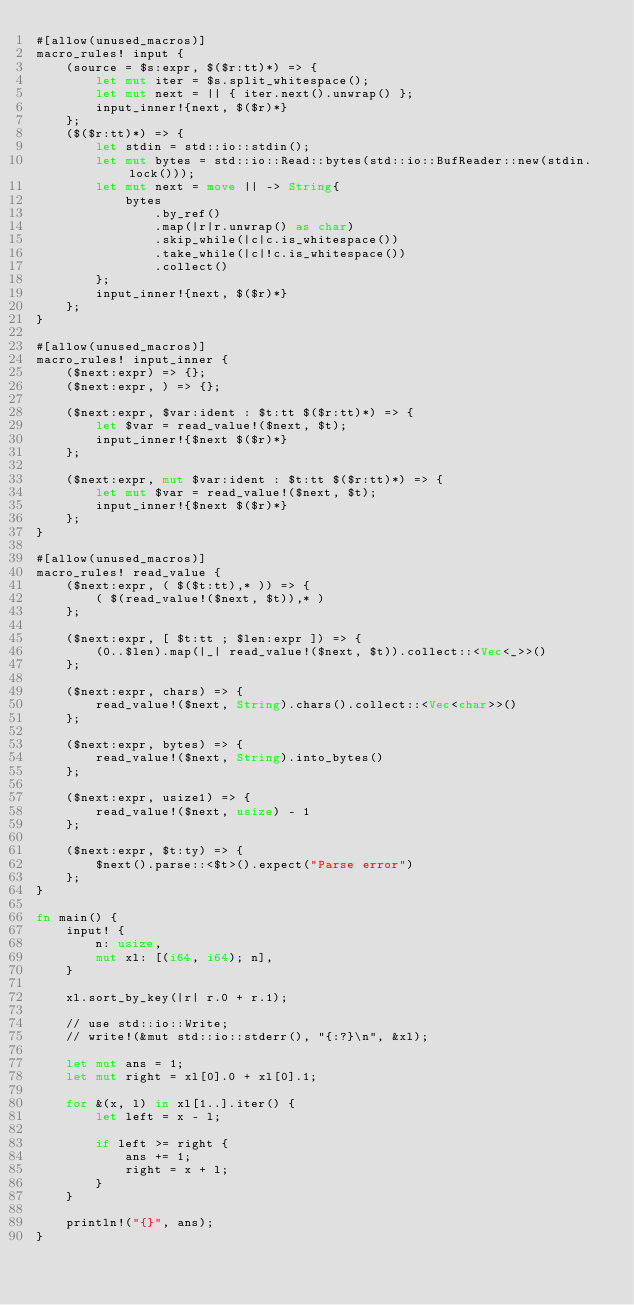<code> <loc_0><loc_0><loc_500><loc_500><_Rust_>#[allow(unused_macros)]
macro_rules! input {
    (source = $s:expr, $($r:tt)*) => {
        let mut iter = $s.split_whitespace();
        let mut next = || { iter.next().unwrap() };
        input_inner!{next, $($r)*}
    };
    ($($r:tt)*) => {
        let stdin = std::io::stdin();
        let mut bytes = std::io::Read::bytes(std::io::BufReader::new(stdin.lock()));
        let mut next = move || -> String{
            bytes
                .by_ref()
                .map(|r|r.unwrap() as char)
                .skip_while(|c|c.is_whitespace())
                .take_while(|c|!c.is_whitespace())
                .collect()
        };
        input_inner!{next, $($r)*}
    };
}

#[allow(unused_macros)]
macro_rules! input_inner {
    ($next:expr) => {};
    ($next:expr, ) => {};

    ($next:expr, $var:ident : $t:tt $($r:tt)*) => {
        let $var = read_value!($next, $t);
        input_inner!{$next $($r)*}
    };

    ($next:expr, mut $var:ident : $t:tt $($r:tt)*) => {
        let mut $var = read_value!($next, $t);
        input_inner!{$next $($r)*}
    };
}

#[allow(unused_macros)]
macro_rules! read_value {
    ($next:expr, ( $($t:tt),* )) => {
        ( $(read_value!($next, $t)),* )
    };

    ($next:expr, [ $t:tt ; $len:expr ]) => {
        (0..$len).map(|_| read_value!($next, $t)).collect::<Vec<_>>()
    };

    ($next:expr, chars) => {
        read_value!($next, String).chars().collect::<Vec<char>>()
    };

    ($next:expr, bytes) => {
        read_value!($next, String).into_bytes()
    };

    ($next:expr, usize1) => {
        read_value!($next, usize) - 1
    };

    ($next:expr, $t:ty) => {
        $next().parse::<$t>().expect("Parse error")
    };
}

fn main() {
    input! {
        n: usize,
        mut xl: [(i64, i64); n],
    }

    xl.sort_by_key(|r| r.0 + r.1);

    // use std::io::Write;
    // write!(&mut std::io::stderr(), "{:?}\n", &xl);

    let mut ans = 1;
    let mut right = xl[0].0 + xl[0].1;

    for &(x, l) in xl[1..].iter() {
        let left = x - l;

        if left >= right {
            ans += 1;
            right = x + l;
        }
    }

    println!("{}", ans);
}
</code> 